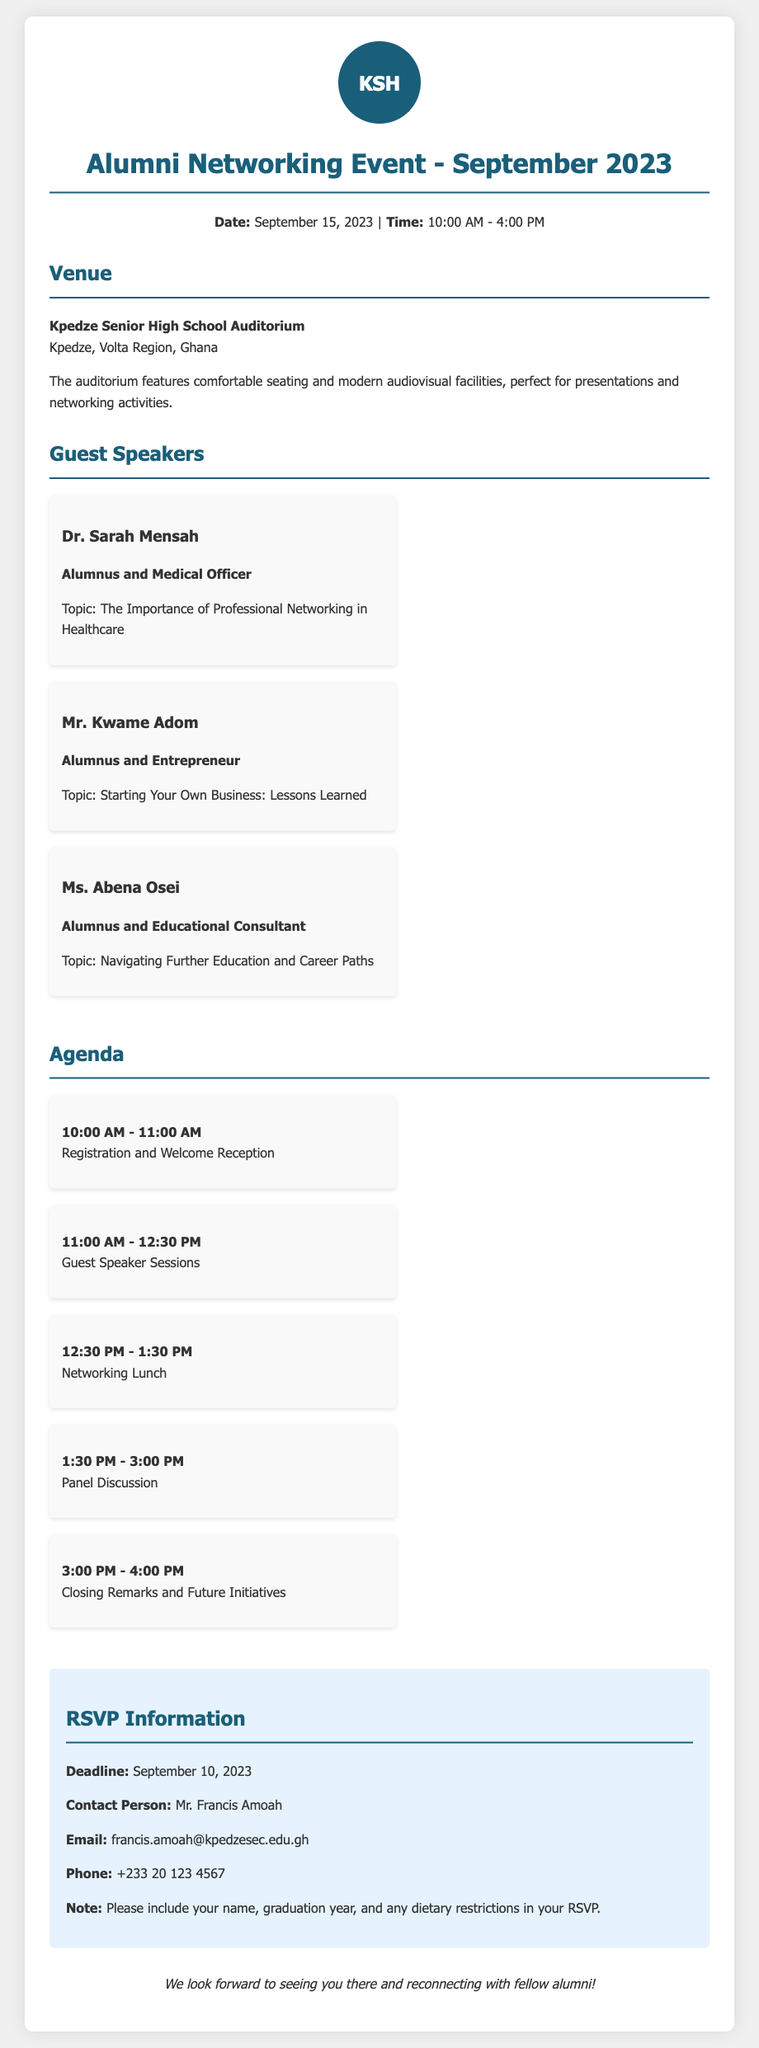What is the date of the Alumni Networking Event? The date of the event is explicitly stated in the document as September 15, 2023.
Answer: September 15, 2023 Where is the event being held? The venue is listed in the document as Kpedze Senior High School Auditorium along with its location.
Answer: Kpedze Senior High School Auditorium Who are the guest speakers at the event? The names of guest speakers are detailed in the document, including Dr. Sarah Mensah, Mr. Kwame Adom, and Ms. Abena Osei.
Answer: Dr. Sarah Mensah, Mr. Kwame Adom, Ms. Abena Osei What is the deadline for RSVPing? The RSVP deadline is mentioned clearly in the document.
Answer: September 10, 2023 What topic will Dr. Sarah Mensah discuss? The document specifies the topic she will discuss during the event.
Answer: The Importance of Professional Networking in Healthcare How long is the networking lunch scheduled to last? The duration of the networking lunch is provided in the agenda section of the document.
Answer: 1 hour What is the contact email for RSVPs? The email for RSVPs is given in the RSVP information section, making it easy to find.
Answer: francis.amoah@kpedzesec.edu.gh What is one requirement for the RSVP? The document outlines a specific requirement that should be included in the RSVP.
Answer: Name, graduation year, and any dietary restrictions 